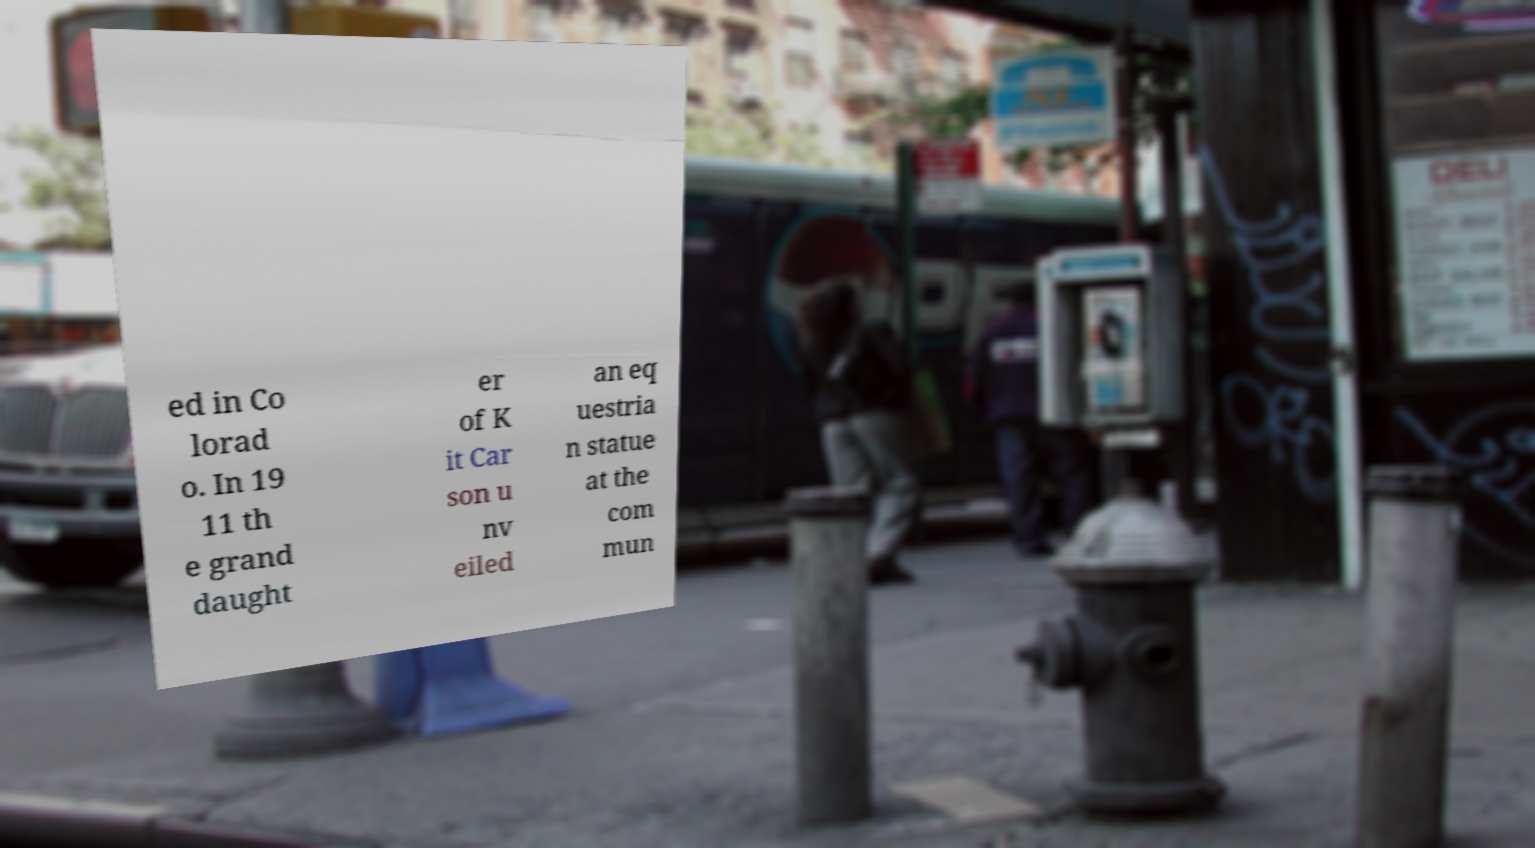For documentation purposes, I need the text within this image transcribed. Could you provide that? ed in Co lorad o. In 19 11 th e grand daught er of K it Car son u nv eiled an eq uestria n statue at the com mun 